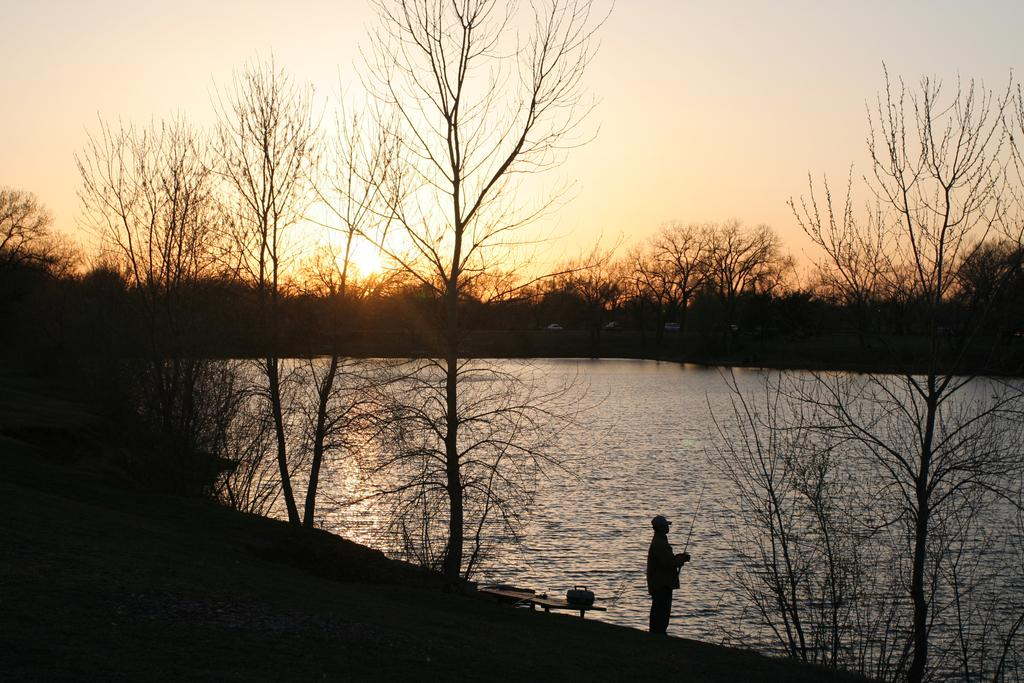What can be seen in the image? There is a person in the image. Can you describe the person's attire? The person is wearing a cap. What is the person holding in the image? The person is holding a stick. What is on the bench in the person is not sitting on? There is a bag on the bench. What type of natural environment is visible in the background? There are trees and water visible in the background. What is visible at the top of the image? The sky is visible at the top of the image. What type of plants are growing in the basin in the image? There is no basin present in the image, and therefore no plants growing in it. 